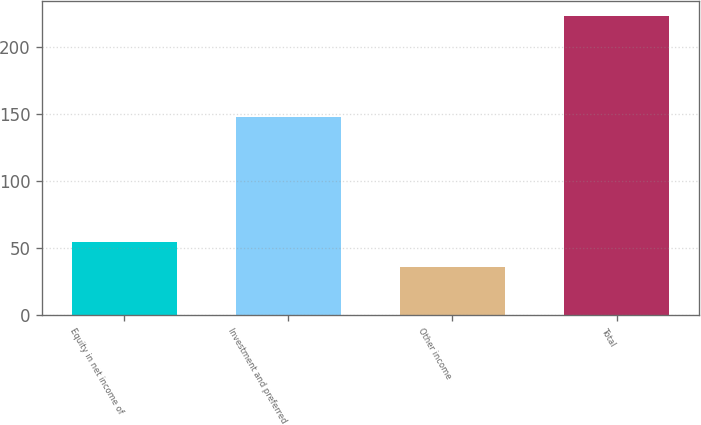Convert chart. <chart><loc_0><loc_0><loc_500><loc_500><bar_chart><fcel>Equity in net income of<fcel>Investment and preferred<fcel>Other income<fcel>Total<nl><fcel>54.45<fcel>147.9<fcel>35.7<fcel>223.2<nl></chart> 